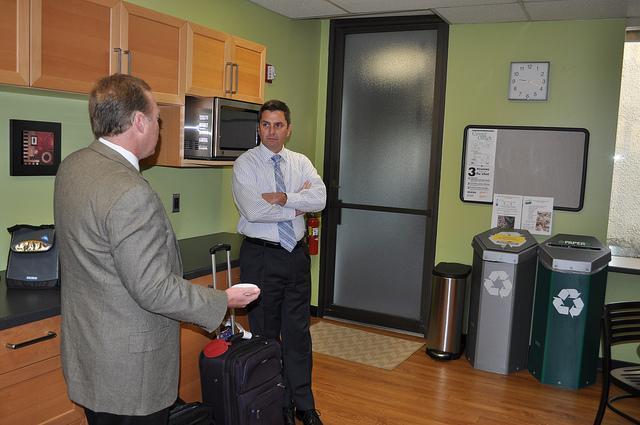How many recycle bins are there?
Give a very brief answer. 2. How many men are there?
Give a very brief answer. 2. How many people are there?
Give a very brief answer. 2. How many different types of bird are in the image?
Give a very brief answer. 0. 